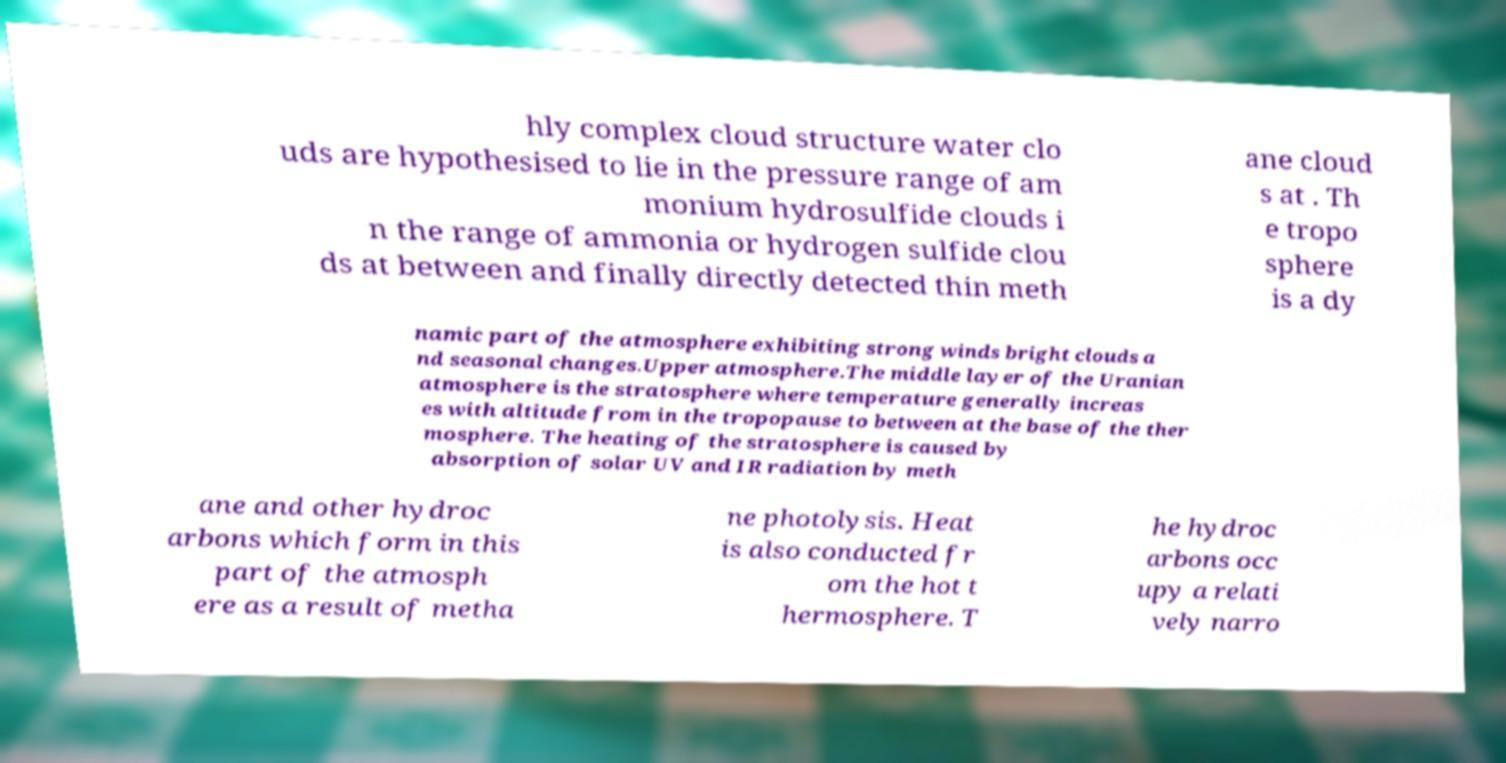Can you read and provide the text displayed in the image?This photo seems to have some interesting text. Can you extract and type it out for me? hly complex cloud structure water clo uds are hypothesised to lie in the pressure range of am monium hydrosulfide clouds i n the range of ammonia or hydrogen sulfide clou ds at between and finally directly detected thin meth ane cloud s at . Th e tropo sphere is a dy namic part of the atmosphere exhibiting strong winds bright clouds a nd seasonal changes.Upper atmosphere.The middle layer of the Uranian atmosphere is the stratosphere where temperature generally increas es with altitude from in the tropopause to between at the base of the ther mosphere. The heating of the stratosphere is caused by absorption of solar UV and IR radiation by meth ane and other hydroc arbons which form in this part of the atmosph ere as a result of metha ne photolysis. Heat is also conducted fr om the hot t hermosphere. T he hydroc arbons occ upy a relati vely narro 